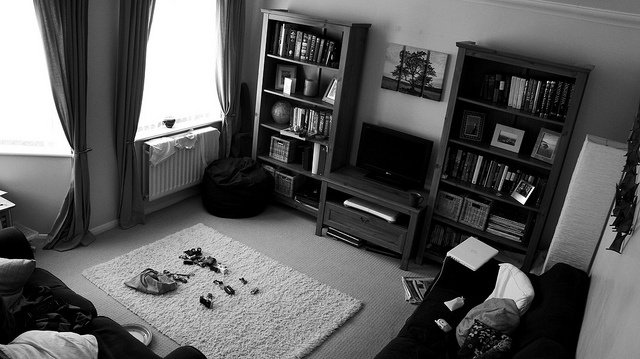Describe the objects in this image and their specific colors. I can see couch in white, black, gray, darkgray, and lightgray tones, couch in white, black, darkgray, gray, and lightgray tones, book in white, black, gray, darkgray, and lightgray tones, tv in black, gray, and white tones, and book in white, black, gray, darkgray, and lightgray tones in this image. 